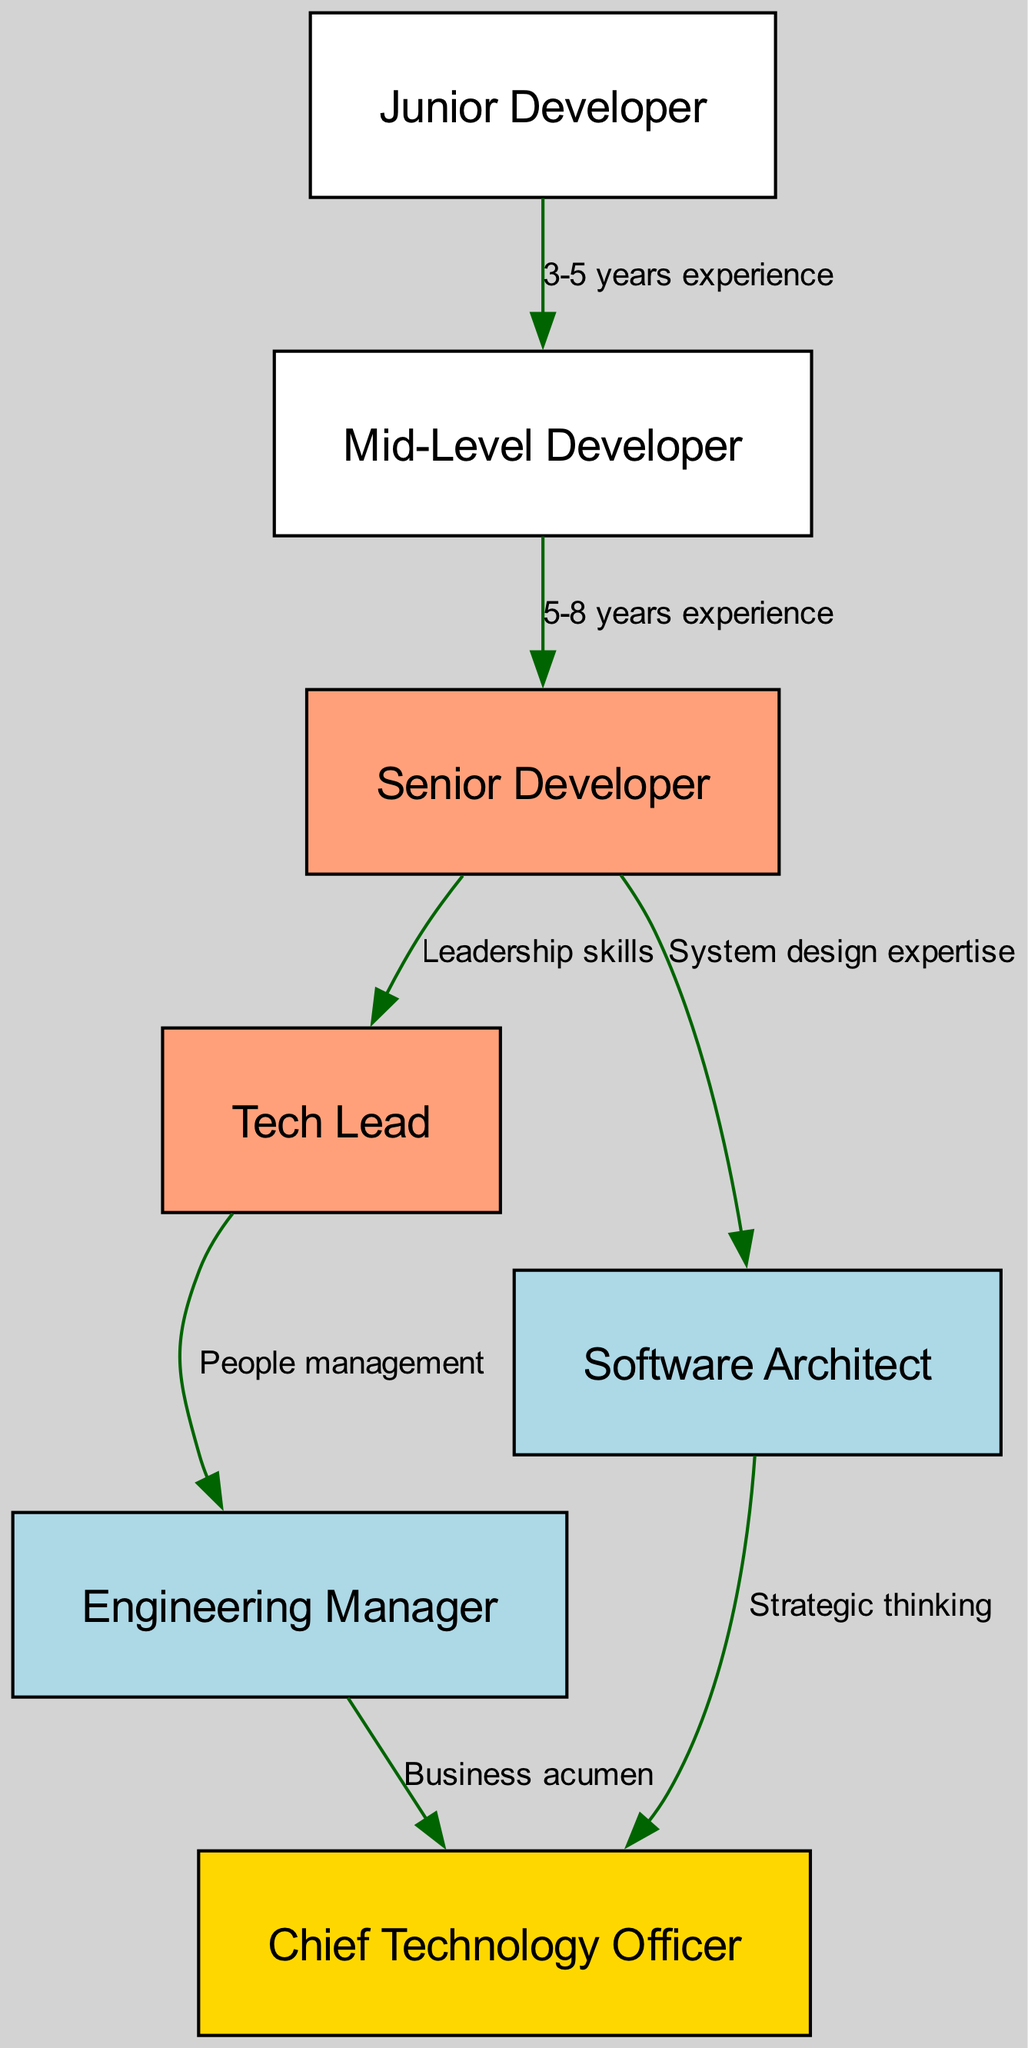What is the starting position in the career progression? The starting position is represented by the node labeled "Junior Developer." This can be found as the first node in the diagram.
Answer: Junior Developer How many years of experience are required to move from Junior Developer to Mid-Level Developer? The edge from "Junior Developer" to "Mid-Level Developer" is labeled with "3-5 years experience." This indicates the necessary experience to make this transition.
Answer: 3-5 years experience Which role requires leadership skills to progress? The transition from "Senior Developer" to "Tech Lead" is labeled with "Leadership skills." This indicates that this role will require those specific skills.
Answer: Tech Lead What is the relationship between Senior Developer and Architect? The diagram shows a direct edge from "Senior Developer" to "Architect," indicating that a Senior Developer can progress to this role based on their "System design expertise." This describes the required skills for this transition.
Answer: System design expertise How many total nodes are present in the diagram? By counting the total number of unique roles represented in the nodes section of the data, there are seven nodes in total, each corresponding to a different role within the career progression.
Answer: 7 What skills are required to be promoted from Tech Lead to Engineering Manager? The edge connecting "Tech Lead" to "Engineering Manager" is labeled with "People management." This means that developing strong people management skills is essential for this promotion.
Answer: People management What does the node labeled "CTO" represent? The node labeled "CTO" stands for "Chief Technology Officer," which is the highest position in the career progression diagram. It signifies the culmination of the career progression path described in the concept map.
Answer: Chief Technology Officer Which position is not directly related to software architecture in career progression? The "Junior Developer" role is the only one that does not directly have a connection leading to architecture-related positions, as all edges leading to higher roles from Junior Developer skip mentioning any architectural skills.
Answer: Junior Developer 